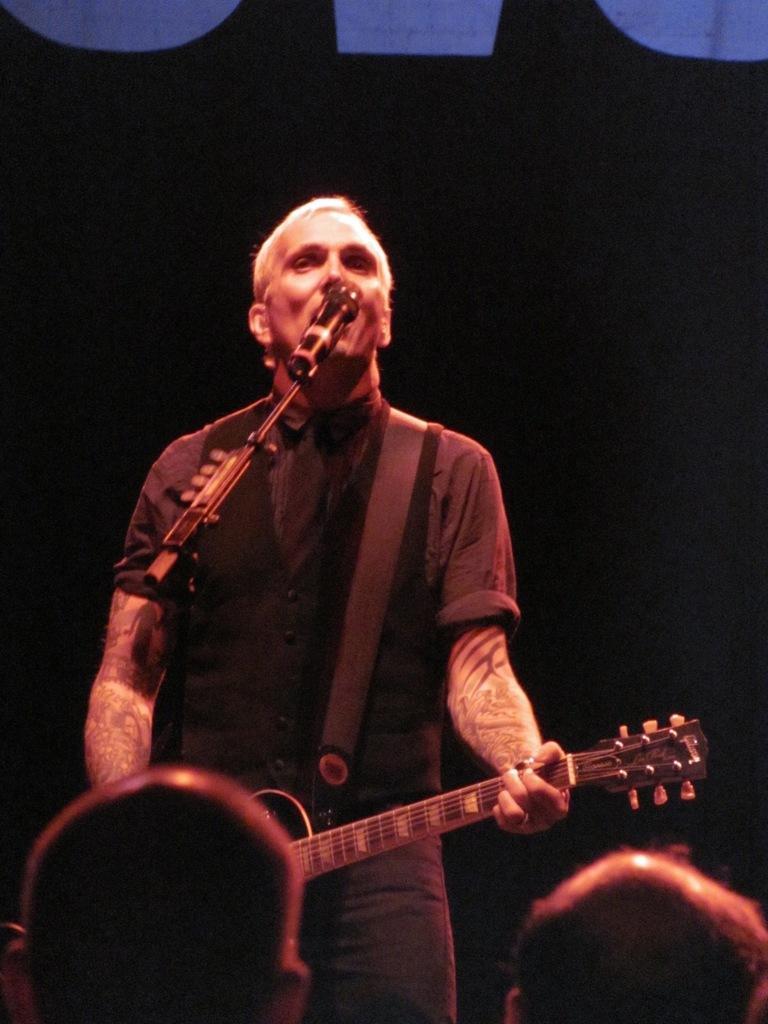In one or two sentences, can you explain what this image depicts? In this image there is a man who is playing the guitar and singing through the mic which is in front of him. There are crowd in front of him. 